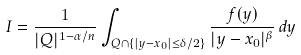<formula> <loc_0><loc_0><loc_500><loc_500>I = \frac { 1 } { | Q | ^ { 1 - \alpha / n } } \int _ { Q \cap \{ | y - x _ { 0 } | \leq \delta / 2 \} } \frac { f ( y ) } { | y - x _ { 0 } | ^ { \beta } } \, d y</formula> 